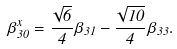Convert formula to latex. <formula><loc_0><loc_0><loc_500><loc_500>\beta _ { 3 0 } ^ { x } = \frac { \sqrt { 6 } } { 4 } \beta _ { 3 1 } - \frac { \sqrt { 1 0 } } { 4 } \beta _ { 3 3 } .</formula> 